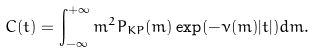<formula> <loc_0><loc_0><loc_500><loc_500>C ( t ) = \int _ { - \infty } ^ { + \infty } m ^ { 2 } P _ { K P } ( m ) \exp ( - \nu ( m ) | t | ) d m .</formula> 